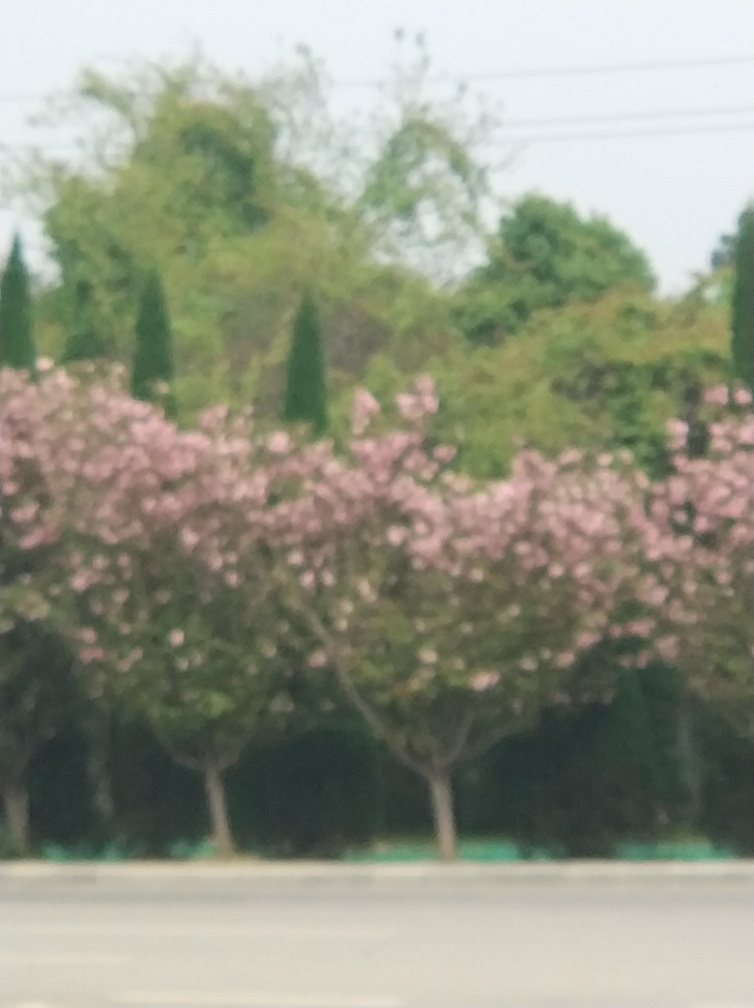Are there any chromatic aberrations?
A. No
B. Yes
Answer with the option's letter from the given choices directly.
 A. 